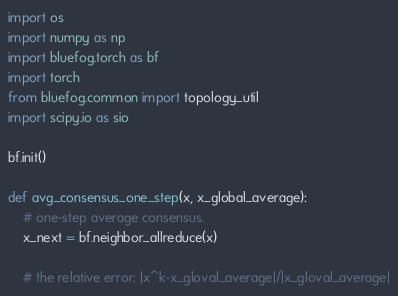Convert code to text. <code><loc_0><loc_0><loc_500><loc_500><_Python_>
import os
import numpy as np
import bluefog.torch as bf
import torch
from bluefog.common import topology_util
import scipy.io as sio

bf.init()

def avg_consensus_one_step(x, x_global_average):
    # one-step average consensus. 
    x_next = bf.neighbor_allreduce(x)
    
    # the relative error: |x^k-x_gloval_average|/|x_gloval_average|</code> 